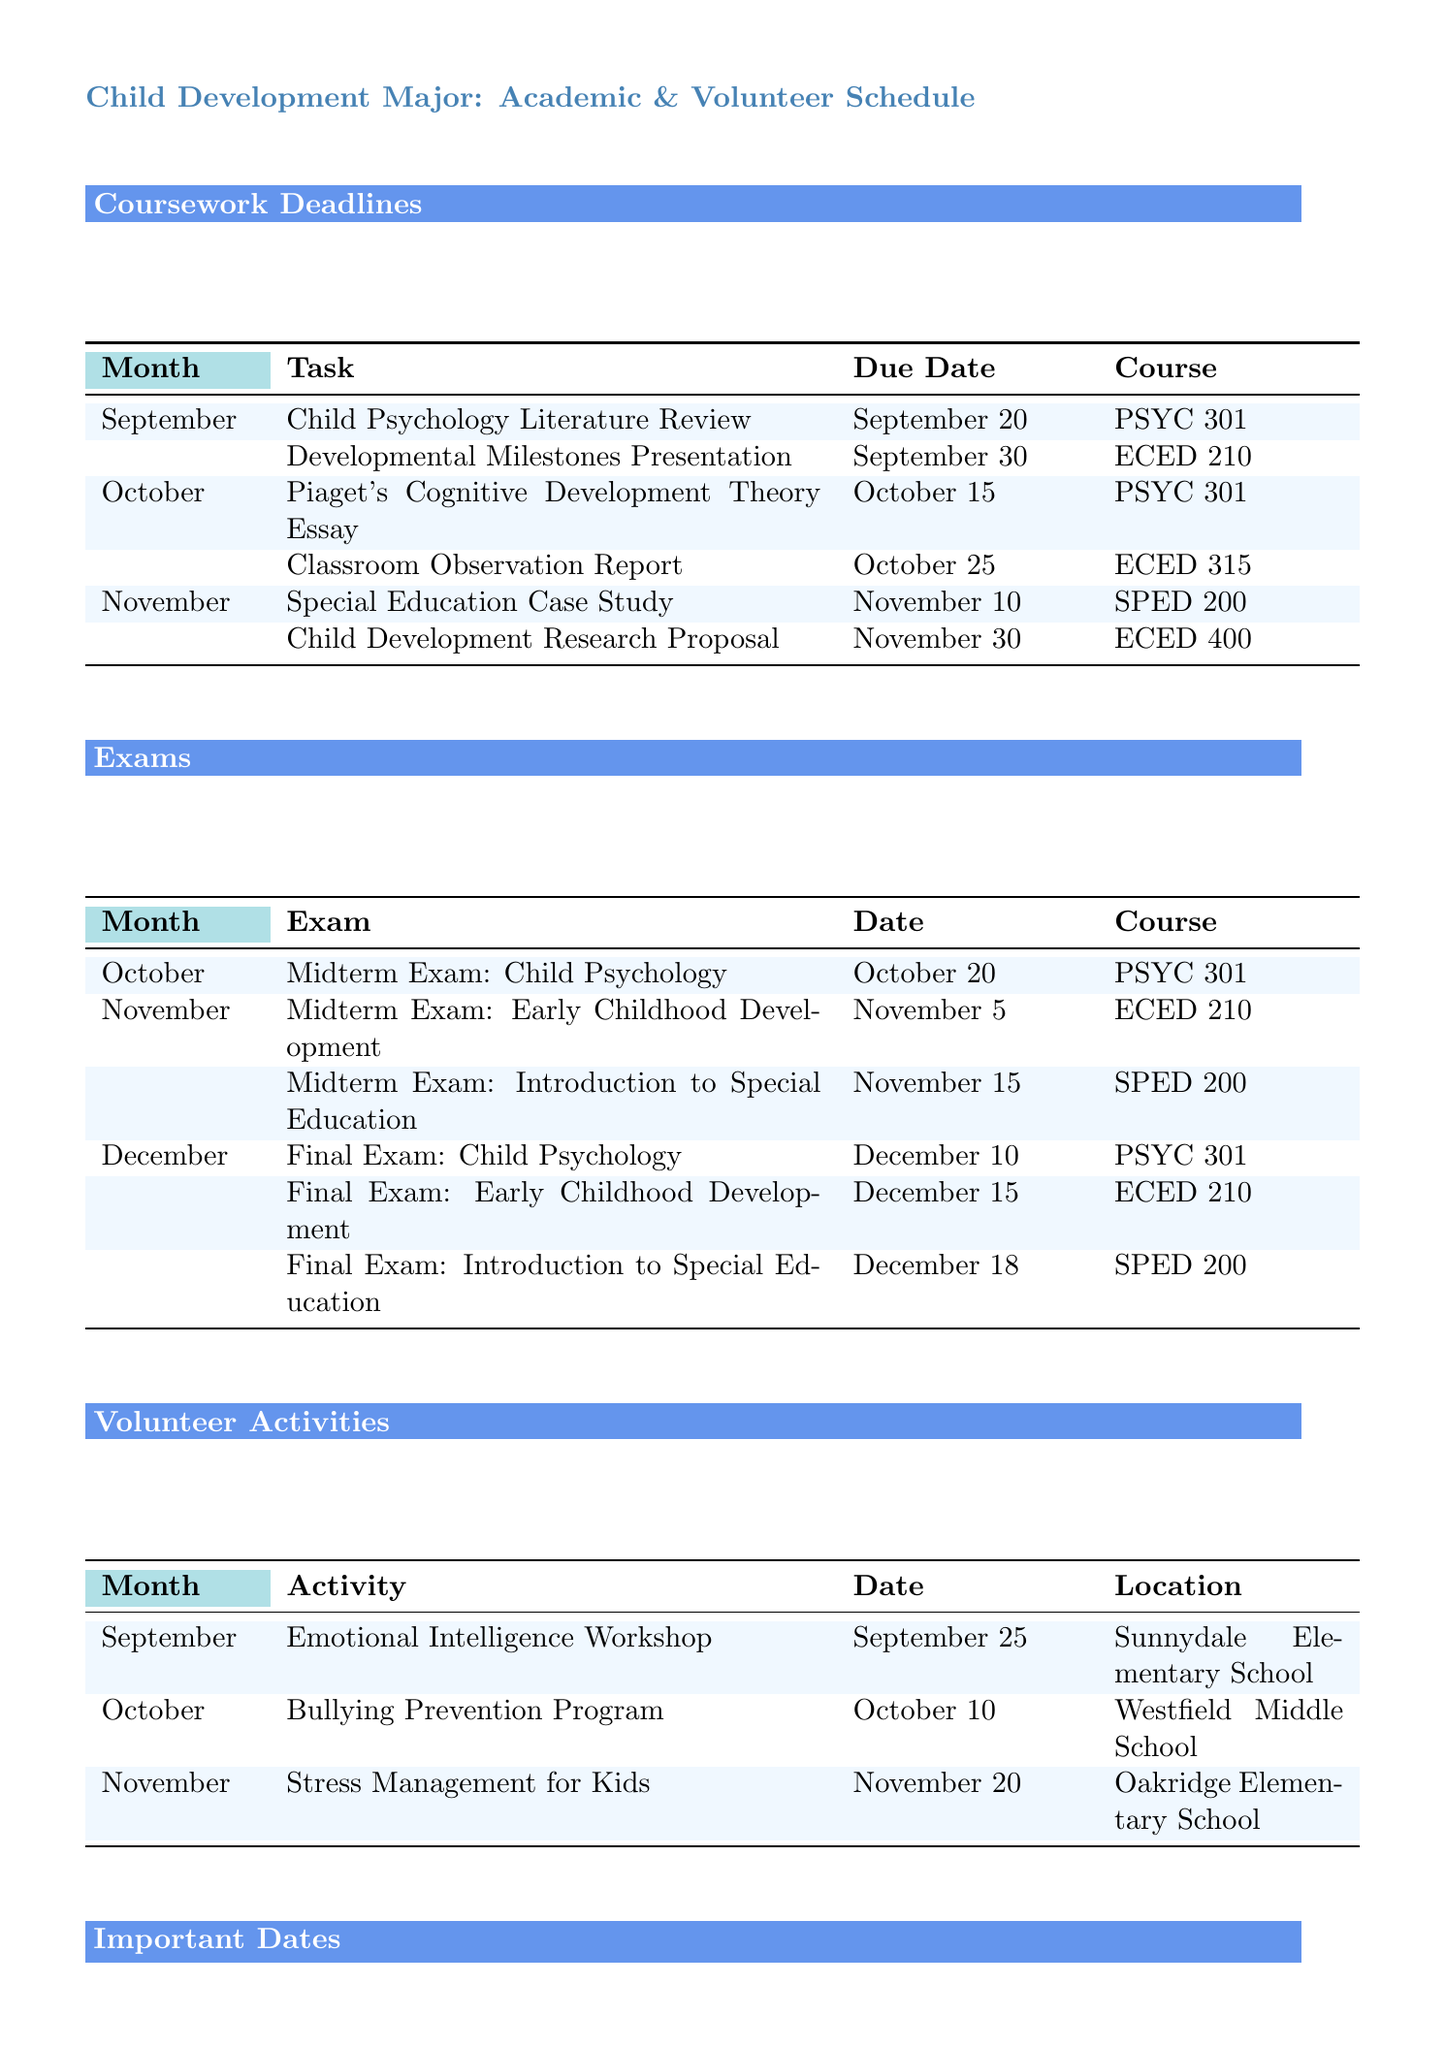what is the due date for the Child Psychology Literature Review? The due date for this task is explicitly mentioned in the document as September 20.
Answer: September 20 who is the guest lecture on October 5? The document specifies Dr. Emily Thompson as the guest lecturer on that date.
Answer: Dr. Emily Thompson how many midterm exams are listed for November? The document shows two midterm exams scheduled for November.
Answer: 2 when is the Emotional Intelligence Workshop? This activity is specifically noted in the document to be on September 25.
Answer: September 25 what course is the Final Exam: Early Childhood Development associated with? The course related to this exam is indicated in the document as ECED 210.
Answer: ECED 210 which month has a due date for the Special Education Case Study? The document identifies November as the month for this assignment's due date.
Answer: November what is the location for the Stress Management for Kids activity? The document provides the specific location as Oakridge Elementary School.
Answer: Oakridge Elementary School how many coursework deadlines are there in October? The document lists two tasks with deadlines in October.
Answer: 2 which event is scheduled for December 5? The document states that the Research Symposium: Children's Emotional Well-being takes place on this date.
Answer: Research Symposium: Children's Emotional Well-being 